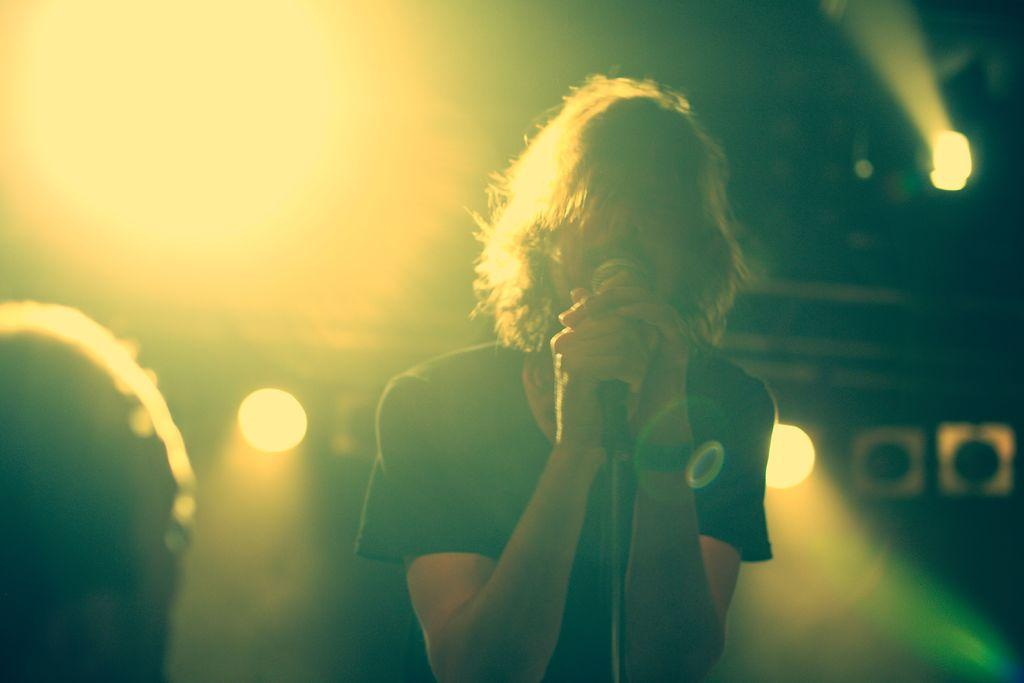What is the main subject of the image? The main subject of the image is a man. What is the man doing in the image? The man is standing and holding a microphone. What can be seen on the left side of the image? There is an object on the left side of the image. What is visible in the background of the image? There are lights visible on the backside of the image. What is the weight of the rabbit in the image? There is no rabbit present in the image, so it is not possible to determine its weight. 